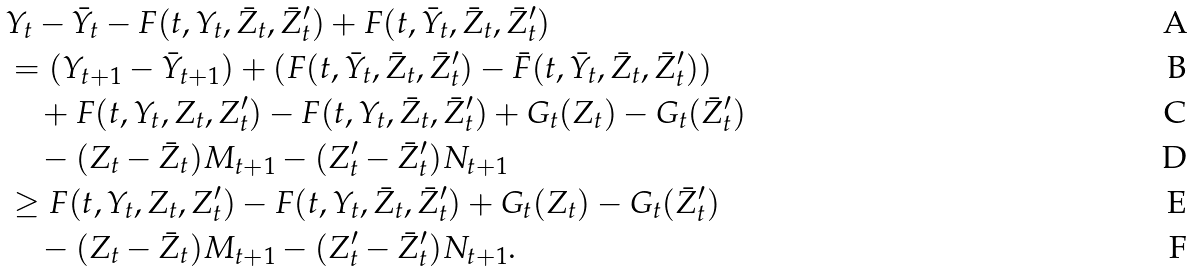Convert formula to latex. <formula><loc_0><loc_0><loc_500><loc_500>& Y _ { t } - \bar { Y } _ { t } - F ( t , Y _ { t } , \bar { Z } _ { t } , \bar { Z } ^ { \prime } _ { t } ) + F ( t , \bar { Y } _ { t } , \bar { Z } _ { t } , \bar { Z } ^ { \prime } _ { t } ) \\ & = ( Y _ { t + 1 } - \bar { Y } _ { t + 1 } ) + ( F ( t , \bar { Y } _ { t } , \bar { Z } _ { t } , \bar { Z } ^ { \prime } _ { t } ) - \bar { F } ( t , \bar { Y } _ { t } , \bar { Z } _ { t } , \bar { Z } ^ { \prime } _ { t } ) ) \\ & \quad + F ( t , Y _ { t } , Z _ { t } , Z ^ { \prime } _ { t } ) - F ( t , Y _ { t } , \bar { Z } _ { t } , \bar { Z } ^ { \prime } _ { t } ) + G _ { t } ( Z _ { t } ) - G _ { t } ( \bar { Z } ^ { \prime } _ { t } ) \\ & \quad - ( Z _ { t } - \bar { Z } _ { t } ) M _ { t + 1 } - ( Z ^ { \prime } _ { t } - \bar { Z } ^ { \prime } _ { t } ) N _ { t + 1 } \\ & \geq F ( t , Y _ { t } , Z _ { t } , Z ^ { \prime } _ { t } ) - F ( t , Y _ { t } , \bar { Z } _ { t } , \bar { Z } ^ { \prime } _ { t } ) + G _ { t } ( Z _ { t } ) - G _ { t } ( \bar { Z } ^ { \prime } _ { t } ) \\ & \quad - ( Z _ { t } - \bar { Z } _ { t } ) M _ { t + 1 } - ( Z ^ { \prime } _ { t } - \bar { Z } ^ { \prime } _ { t } ) N _ { t + 1 } .</formula> 